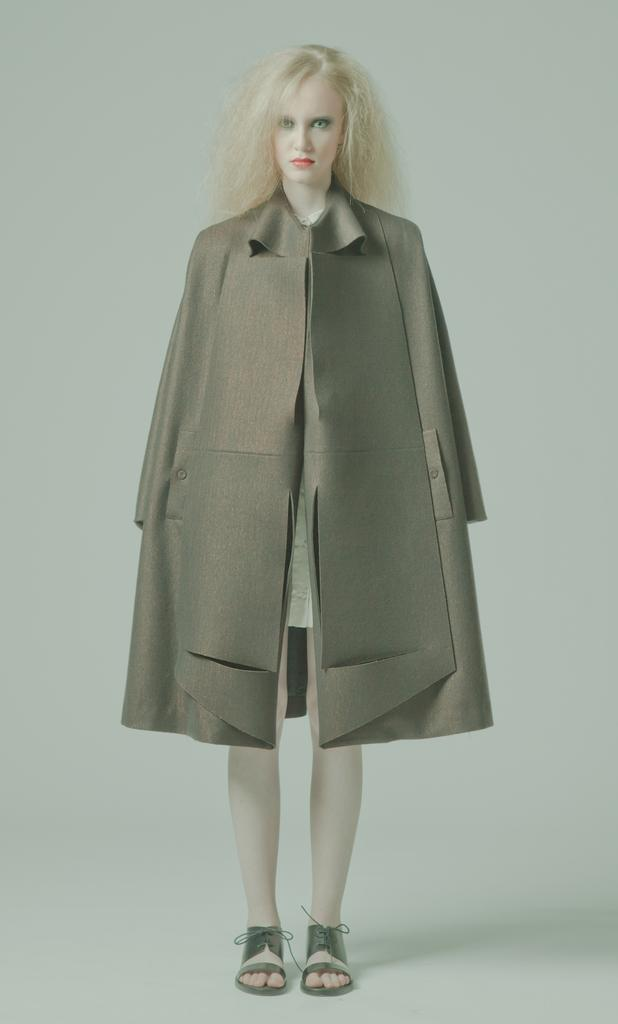Who is present in the image? There is a lady in the image. What is the lady doing in the image? The lady is standing. What type of clothing is the lady wearing in the image? The lady is wearing a jacket. What type of tools is the lady using as a carpenter in the image? There is no indication in the image that the lady is a carpenter or using any tools. What kind of animal can be seen interacting with the lady in the image? There are no animals present in the image. 